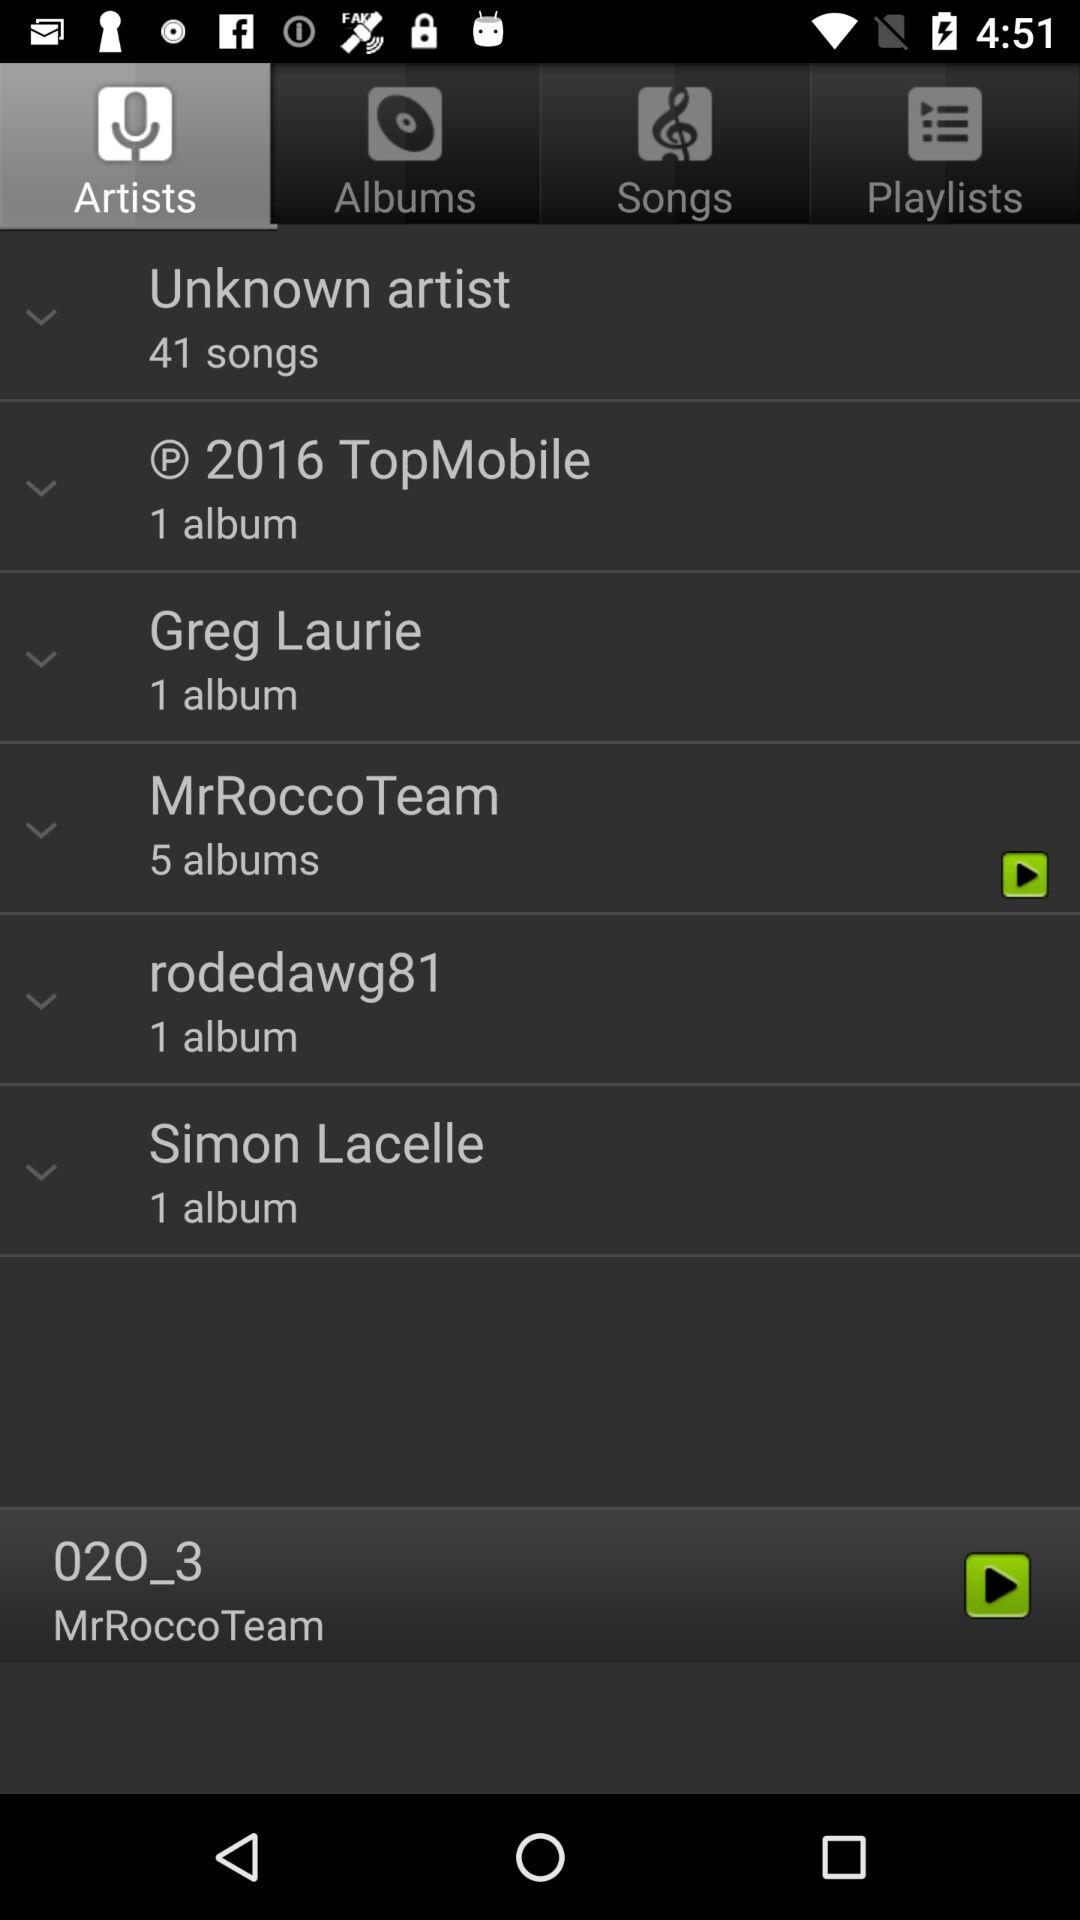Which tab is selected? The selected tab is "Artists". 